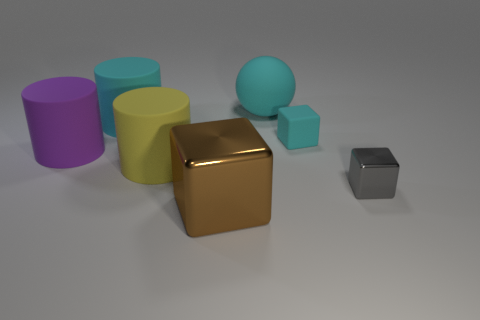Subtract all brown cubes. How many cubes are left? 2 Add 3 cyan blocks. How many objects exist? 10 Subtract all cyan blocks. How many blocks are left? 2 Subtract all cylinders. How many objects are left? 4 Subtract 2 cylinders. How many cylinders are left? 1 Subtract 0 purple balls. How many objects are left? 7 Subtract all brown cylinders. Subtract all gray cubes. How many cylinders are left? 3 Subtract all blue cylinders. How many brown blocks are left? 1 Subtract all large yellow metallic cubes. Subtract all brown metallic things. How many objects are left? 6 Add 4 metallic objects. How many metallic objects are left? 6 